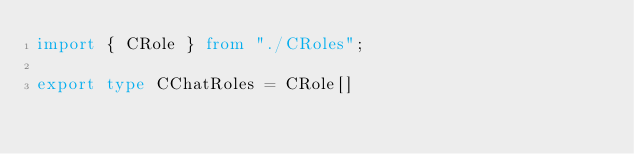Convert code to text. <code><loc_0><loc_0><loc_500><loc_500><_TypeScript_>import { CRole } from "./CRoles";

export type CChatRoles = CRole[]</code> 